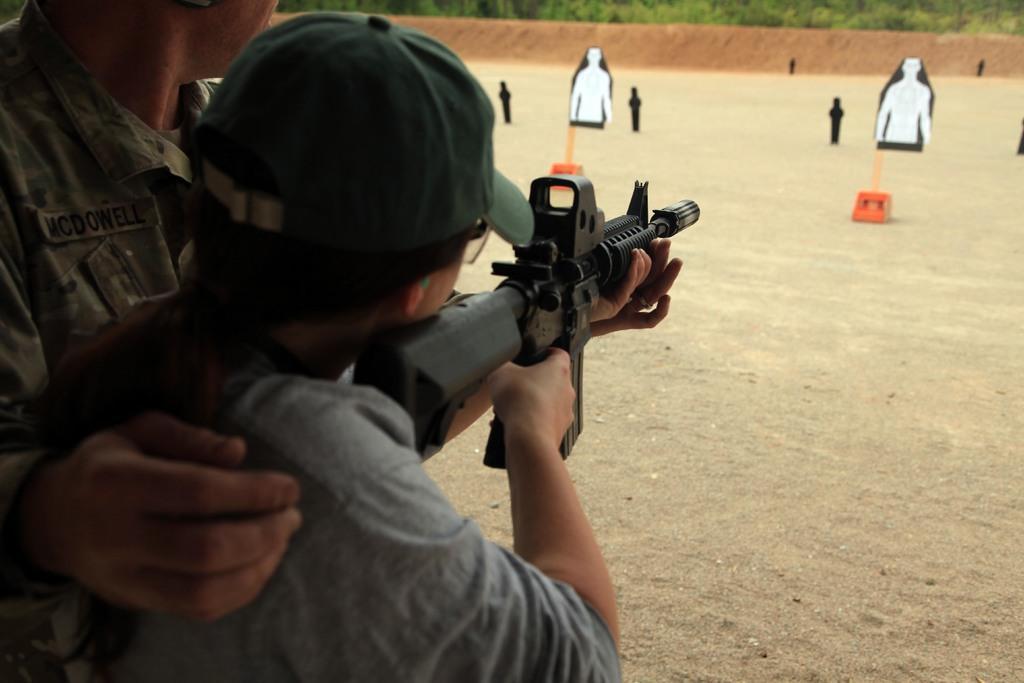Describe this image in one or two sentences. In this picture we can see a person wearing a cap and holding a gun. We can see some text on the dress of a man. There are some orange objects, images of persons on the objects, other objects and some greenery in the background. 